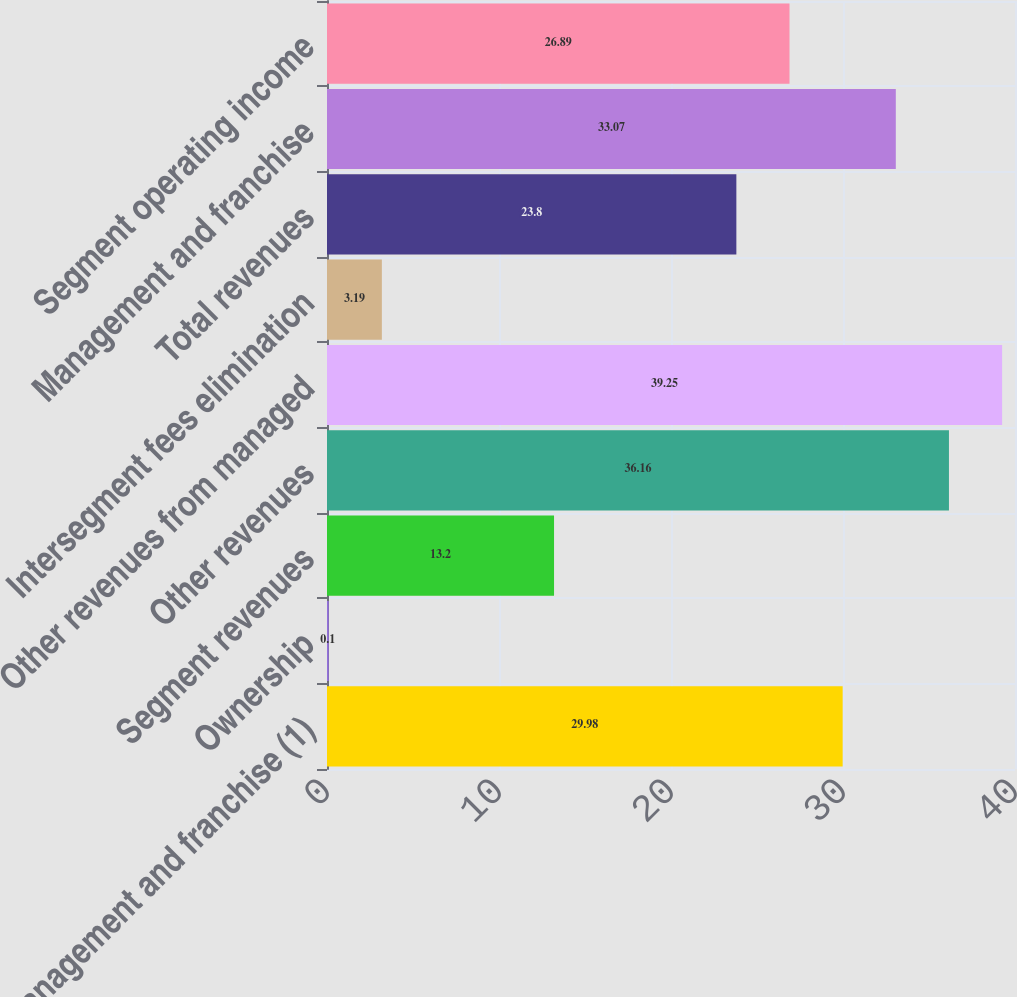<chart> <loc_0><loc_0><loc_500><loc_500><bar_chart><fcel>Management and franchise (1)<fcel>Ownership<fcel>Segment revenues<fcel>Other revenues<fcel>Other revenues from managed<fcel>Intersegment fees elimination<fcel>Total revenues<fcel>Management and franchise<fcel>Segment operating income<nl><fcel>29.98<fcel>0.1<fcel>13.2<fcel>36.16<fcel>39.25<fcel>3.19<fcel>23.8<fcel>33.07<fcel>26.89<nl></chart> 